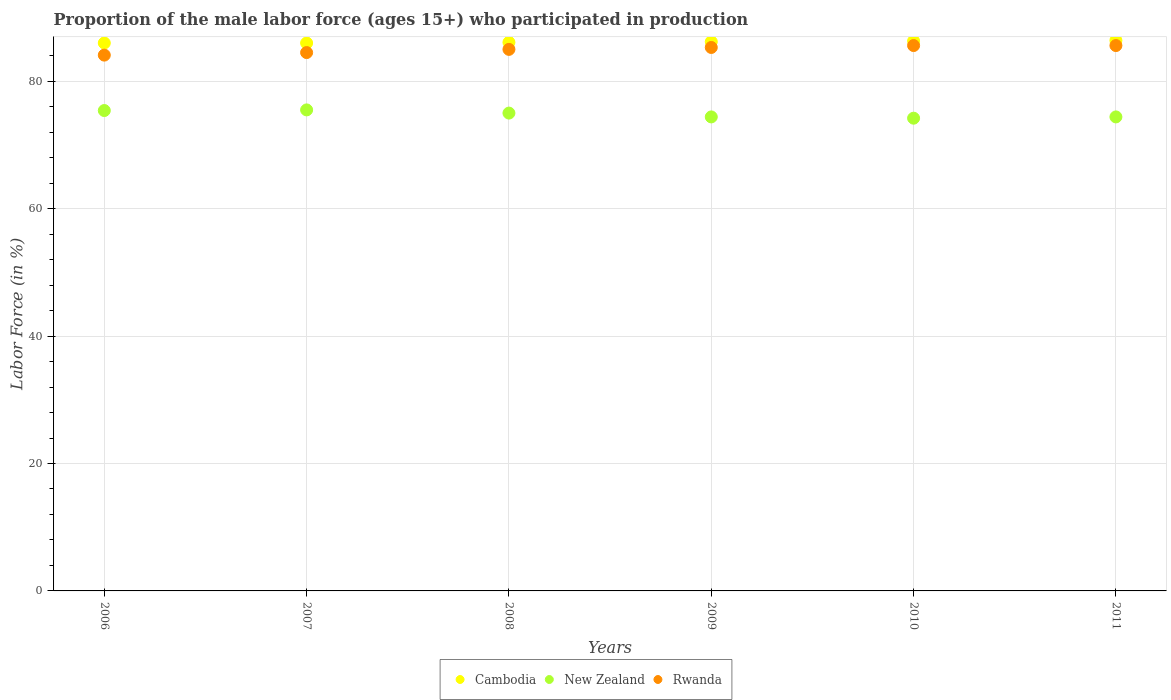What is the proportion of the male labor force who participated in production in Cambodia in 2007?
Your answer should be very brief. 86. Across all years, what is the maximum proportion of the male labor force who participated in production in New Zealand?
Offer a very short reply. 75.5. Across all years, what is the minimum proportion of the male labor force who participated in production in New Zealand?
Keep it short and to the point. 74.2. What is the total proportion of the male labor force who participated in production in Rwanda in the graph?
Keep it short and to the point. 510.1. What is the difference between the proportion of the male labor force who participated in production in New Zealand in 2009 and that in 2010?
Provide a succinct answer. 0.2. What is the difference between the proportion of the male labor force who participated in production in Rwanda in 2011 and the proportion of the male labor force who participated in production in New Zealand in 2007?
Your answer should be very brief. 10.1. What is the average proportion of the male labor force who participated in production in New Zealand per year?
Give a very brief answer. 74.82. In how many years, is the proportion of the male labor force who participated in production in Rwanda greater than 16 %?
Your answer should be compact. 6. What is the ratio of the proportion of the male labor force who participated in production in New Zealand in 2010 to that in 2011?
Offer a terse response. 1. Is the difference between the proportion of the male labor force who participated in production in New Zealand in 2006 and 2008 greater than the difference between the proportion of the male labor force who participated in production in Rwanda in 2006 and 2008?
Ensure brevity in your answer.  Yes. What is the difference between the highest and the second highest proportion of the male labor force who participated in production in Cambodia?
Provide a succinct answer. 0.1. What is the difference between the highest and the lowest proportion of the male labor force who participated in production in Rwanda?
Keep it short and to the point. 1.5. In how many years, is the proportion of the male labor force who participated in production in Cambodia greater than the average proportion of the male labor force who participated in production in Cambodia taken over all years?
Your response must be concise. 3. Is it the case that in every year, the sum of the proportion of the male labor force who participated in production in Rwanda and proportion of the male labor force who participated in production in New Zealand  is greater than the proportion of the male labor force who participated in production in Cambodia?
Ensure brevity in your answer.  Yes. Is the proportion of the male labor force who participated in production in New Zealand strictly greater than the proportion of the male labor force who participated in production in Cambodia over the years?
Make the answer very short. No. How many dotlines are there?
Offer a very short reply. 3. How many years are there in the graph?
Give a very brief answer. 6. What is the difference between two consecutive major ticks on the Y-axis?
Make the answer very short. 20. Does the graph contain grids?
Your answer should be very brief. Yes. Where does the legend appear in the graph?
Offer a terse response. Bottom center. How are the legend labels stacked?
Keep it short and to the point. Horizontal. What is the title of the graph?
Your response must be concise. Proportion of the male labor force (ages 15+) who participated in production. Does "Heavily indebted poor countries" appear as one of the legend labels in the graph?
Make the answer very short. No. What is the Labor Force (in %) of Cambodia in 2006?
Make the answer very short. 86. What is the Labor Force (in %) in New Zealand in 2006?
Ensure brevity in your answer.  75.4. What is the Labor Force (in %) in Rwanda in 2006?
Offer a very short reply. 84.1. What is the Labor Force (in %) in New Zealand in 2007?
Your response must be concise. 75.5. What is the Labor Force (in %) in Rwanda in 2007?
Give a very brief answer. 84.5. What is the Labor Force (in %) of Cambodia in 2008?
Give a very brief answer. 86.1. What is the Labor Force (in %) of Rwanda in 2008?
Ensure brevity in your answer.  85. What is the Labor Force (in %) in Cambodia in 2009?
Your answer should be very brief. 86.2. What is the Labor Force (in %) of New Zealand in 2009?
Give a very brief answer. 74.4. What is the Labor Force (in %) in Rwanda in 2009?
Provide a succinct answer. 85.3. What is the Labor Force (in %) in Cambodia in 2010?
Provide a succinct answer. 86.3. What is the Labor Force (in %) in New Zealand in 2010?
Provide a short and direct response. 74.2. What is the Labor Force (in %) of Rwanda in 2010?
Give a very brief answer. 85.6. What is the Labor Force (in %) of Cambodia in 2011?
Your response must be concise. 86.4. What is the Labor Force (in %) in New Zealand in 2011?
Make the answer very short. 74.4. What is the Labor Force (in %) in Rwanda in 2011?
Make the answer very short. 85.6. Across all years, what is the maximum Labor Force (in %) in Cambodia?
Your answer should be compact. 86.4. Across all years, what is the maximum Labor Force (in %) of New Zealand?
Make the answer very short. 75.5. Across all years, what is the maximum Labor Force (in %) in Rwanda?
Give a very brief answer. 85.6. Across all years, what is the minimum Labor Force (in %) in Cambodia?
Offer a very short reply. 86. Across all years, what is the minimum Labor Force (in %) in New Zealand?
Offer a very short reply. 74.2. Across all years, what is the minimum Labor Force (in %) in Rwanda?
Offer a very short reply. 84.1. What is the total Labor Force (in %) of Cambodia in the graph?
Ensure brevity in your answer.  517. What is the total Labor Force (in %) of New Zealand in the graph?
Ensure brevity in your answer.  448.9. What is the total Labor Force (in %) of Rwanda in the graph?
Provide a short and direct response. 510.1. What is the difference between the Labor Force (in %) of Cambodia in 2006 and that in 2007?
Your answer should be very brief. 0. What is the difference between the Labor Force (in %) in New Zealand in 2006 and that in 2007?
Your answer should be compact. -0.1. What is the difference between the Labor Force (in %) of Rwanda in 2006 and that in 2008?
Provide a short and direct response. -0.9. What is the difference between the Labor Force (in %) in New Zealand in 2006 and that in 2009?
Keep it short and to the point. 1. What is the difference between the Labor Force (in %) of Rwanda in 2006 and that in 2010?
Give a very brief answer. -1.5. What is the difference between the Labor Force (in %) in Cambodia in 2006 and that in 2011?
Your answer should be very brief. -0.4. What is the difference between the Labor Force (in %) in Cambodia in 2007 and that in 2009?
Make the answer very short. -0.2. What is the difference between the Labor Force (in %) of Cambodia in 2007 and that in 2010?
Your answer should be compact. -0.3. What is the difference between the Labor Force (in %) in Cambodia in 2007 and that in 2011?
Make the answer very short. -0.4. What is the difference between the Labor Force (in %) in Rwanda in 2007 and that in 2011?
Keep it short and to the point. -1.1. What is the difference between the Labor Force (in %) of Cambodia in 2008 and that in 2009?
Ensure brevity in your answer.  -0.1. What is the difference between the Labor Force (in %) of New Zealand in 2008 and that in 2009?
Give a very brief answer. 0.6. What is the difference between the Labor Force (in %) in Rwanda in 2008 and that in 2009?
Your answer should be compact. -0.3. What is the difference between the Labor Force (in %) of Cambodia in 2008 and that in 2010?
Provide a short and direct response. -0.2. What is the difference between the Labor Force (in %) in New Zealand in 2008 and that in 2010?
Provide a short and direct response. 0.8. What is the difference between the Labor Force (in %) in Rwanda in 2008 and that in 2010?
Offer a very short reply. -0.6. What is the difference between the Labor Force (in %) of Rwanda in 2008 and that in 2011?
Keep it short and to the point. -0.6. What is the difference between the Labor Force (in %) in Cambodia in 2009 and that in 2010?
Keep it short and to the point. -0.1. What is the difference between the Labor Force (in %) in Cambodia in 2009 and that in 2011?
Provide a succinct answer. -0.2. What is the difference between the Labor Force (in %) in New Zealand in 2009 and that in 2011?
Give a very brief answer. 0. What is the difference between the Labor Force (in %) of Rwanda in 2009 and that in 2011?
Offer a terse response. -0.3. What is the difference between the Labor Force (in %) in New Zealand in 2010 and that in 2011?
Offer a very short reply. -0.2. What is the difference between the Labor Force (in %) in Rwanda in 2010 and that in 2011?
Offer a very short reply. 0. What is the difference between the Labor Force (in %) of Cambodia in 2006 and the Labor Force (in %) of New Zealand in 2007?
Your answer should be compact. 10.5. What is the difference between the Labor Force (in %) of Cambodia in 2006 and the Labor Force (in %) of Rwanda in 2007?
Keep it short and to the point. 1.5. What is the difference between the Labor Force (in %) of New Zealand in 2006 and the Labor Force (in %) of Rwanda in 2008?
Give a very brief answer. -9.6. What is the difference between the Labor Force (in %) of New Zealand in 2006 and the Labor Force (in %) of Rwanda in 2009?
Your answer should be compact. -9.9. What is the difference between the Labor Force (in %) of Cambodia in 2006 and the Labor Force (in %) of New Zealand in 2010?
Offer a terse response. 11.8. What is the difference between the Labor Force (in %) in New Zealand in 2006 and the Labor Force (in %) in Rwanda in 2010?
Your answer should be very brief. -10.2. What is the difference between the Labor Force (in %) in Cambodia in 2006 and the Labor Force (in %) in Rwanda in 2011?
Provide a short and direct response. 0.4. What is the difference between the Labor Force (in %) in New Zealand in 2006 and the Labor Force (in %) in Rwanda in 2011?
Offer a terse response. -10.2. What is the difference between the Labor Force (in %) in Cambodia in 2007 and the Labor Force (in %) in Rwanda in 2008?
Your response must be concise. 1. What is the difference between the Labor Force (in %) in Cambodia in 2007 and the Labor Force (in %) in New Zealand in 2009?
Your response must be concise. 11.6. What is the difference between the Labor Force (in %) in New Zealand in 2008 and the Labor Force (in %) in Rwanda in 2009?
Your response must be concise. -10.3. What is the difference between the Labor Force (in %) in Cambodia in 2008 and the Labor Force (in %) in New Zealand in 2010?
Offer a very short reply. 11.9. What is the difference between the Labor Force (in %) of New Zealand in 2008 and the Labor Force (in %) of Rwanda in 2010?
Offer a terse response. -10.6. What is the difference between the Labor Force (in %) of New Zealand in 2008 and the Labor Force (in %) of Rwanda in 2011?
Provide a short and direct response. -10.6. What is the difference between the Labor Force (in %) in New Zealand in 2009 and the Labor Force (in %) in Rwanda in 2010?
Offer a terse response. -11.2. What is the difference between the Labor Force (in %) of Cambodia in 2009 and the Labor Force (in %) of New Zealand in 2011?
Provide a short and direct response. 11.8. What is the difference between the Labor Force (in %) of Cambodia in 2009 and the Labor Force (in %) of Rwanda in 2011?
Provide a short and direct response. 0.6. What is the difference between the Labor Force (in %) in New Zealand in 2009 and the Labor Force (in %) in Rwanda in 2011?
Ensure brevity in your answer.  -11.2. What is the difference between the Labor Force (in %) in Cambodia in 2010 and the Labor Force (in %) in New Zealand in 2011?
Provide a short and direct response. 11.9. What is the difference between the Labor Force (in %) in New Zealand in 2010 and the Labor Force (in %) in Rwanda in 2011?
Offer a terse response. -11.4. What is the average Labor Force (in %) of Cambodia per year?
Offer a very short reply. 86.17. What is the average Labor Force (in %) in New Zealand per year?
Provide a succinct answer. 74.82. What is the average Labor Force (in %) in Rwanda per year?
Provide a short and direct response. 85.02. In the year 2006, what is the difference between the Labor Force (in %) of Cambodia and Labor Force (in %) of Rwanda?
Keep it short and to the point. 1.9. In the year 2006, what is the difference between the Labor Force (in %) of New Zealand and Labor Force (in %) of Rwanda?
Ensure brevity in your answer.  -8.7. In the year 2007, what is the difference between the Labor Force (in %) of Cambodia and Labor Force (in %) of Rwanda?
Offer a terse response. 1.5. In the year 2008, what is the difference between the Labor Force (in %) of Cambodia and Labor Force (in %) of Rwanda?
Give a very brief answer. 1.1. In the year 2008, what is the difference between the Labor Force (in %) of New Zealand and Labor Force (in %) of Rwanda?
Provide a succinct answer. -10. In the year 2009, what is the difference between the Labor Force (in %) of New Zealand and Labor Force (in %) of Rwanda?
Offer a very short reply. -10.9. In the year 2010, what is the difference between the Labor Force (in %) of New Zealand and Labor Force (in %) of Rwanda?
Ensure brevity in your answer.  -11.4. In the year 2011, what is the difference between the Labor Force (in %) of Cambodia and Labor Force (in %) of Rwanda?
Keep it short and to the point. 0.8. What is the ratio of the Labor Force (in %) of New Zealand in 2006 to that in 2007?
Offer a very short reply. 1. What is the ratio of the Labor Force (in %) in Rwanda in 2006 to that in 2007?
Give a very brief answer. 1. What is the ratio of the Labor Force (in %) in Cambodia in 2006 to that in 2008?
Provide a succinct answer. 1. What is the ratio of the Labor Force (in %) in New Zealand in 2006 to that in 2008?
Provide a succinct answer. 1.01. What is the ratio of the Labor Force (in %) of Rwanda in 2006 to that in 2008?
Your answer should be compact. 0.99. What is the ratio of the Labor Force (in %) in Cambodia in 2006 to that in 2009?
Your answer should be very brief. 1. What is the ratio of the Labor Force (in %) of New Zealand in 2006 to that in 2009?
Your answer should be very brief. 1.01. What is the ratio of the Labor Force (in %) of Rwanda in 2006 to that in 2009?
Give a very brief answer. 0.99. What is the ratio of the Labor Force (in %) of Cambodia in 2006 to that in 2010?
Offer a very short reply. 1. What is the ratio of the Labor Force (in %) of New Zealand in 2006 to that in 2010?
Provide a short and direct response. 1.02. What is the ratio of the Labor Force (in %) in Rwanda in 2006 to that in 2010?
Offer a very short reply. 0.98. What is the ratio of the Labor Force (in %) in New Zealand in 2006 to that in 2011?
Your answer should be compact. 1.01. What is the ratio of the Labor Force (in %) of Rwanda in 2006 to that in 2011?
Keep it short and to the point. 0.98. What is the ratio of the Labor Force (in %) of Cambodia in 2007 to that in 2008?
Your answer should be very brief. 1. What is the ratio of the Labor Force (in %) in New Zealand in 2007 to that in 2008?
Your response must be concise. 1.01. What is the ratio of the Labor Force (in %) of Cambodia in 2007 to that in 2009?
Your response must be concise. 1. What is the ratio of the Labor Force (in %) of New Zealand in 2007 to that in 2009?
Your answer should be compact. 1.01. What is the ratio of the Labor Force (in %) of Rwanda in 2007 to that in 2009?
Make the answer very short. 0.99. What is the ratio of the Labor Force (in %) of Cambodia in 2007 to that in 2010?
Ensure brevity in your answer.  1. What is the ratio of the Labor Force (in %) in New Zealand in 2007 to that in 2010?
Make the answer very short. 1.02. What is the ratio of the Labor Force (in %) of Rwanda in 2007 to that in 2010?
Provide a succinct answer. 0.99. What is the ratio of the Labor Force (in %) of Cambodia in 2007 to that in 2011?
Your response must be concise. 1. What is the ratio of the Labor Force (in %) in New Zealand in 2007 to that in 2011?
Your answer should be compact. 1.01. What is the ratio of the Labor Force (in %) of Rwanda in 2007 to that in 2011?
Give a very brief answer. 0.99. What is the ratio of the Labor Force (in %) in Cambodia in 2008 to that in 2009?
Keep it short and to the point. 1. What is the ratio of the Labor Force (in %) in New Zealand in 2008 to that in 2009?
Offer a terse response. 1.01. What is the ratio of the Labor Force (in %) in Cambodia in 2008 to that in 2010?
Make the answer very short. 1. What is the ratio of the Labor Force (in %) in New Zealand in 2008 to that in 2010?
Your answer should be very brief. 1.01. What is the ratio of the Labor Force (in %) of Rwanda in 2008 to that in 2010?
Your answer should be compact. 0.99. What is the ratio of the Labor Force (in %) in Cambodia in 2008 to that in 2011?
Your answer should be very brief. 1. What is the ratio of the Labor Force (in %) of New Zealand in 2008 to that in 2011?
Your response must be concise. 1.01. What is the ratio of the Labor Force (in %) in Rwanda in 2008 to that in 2011?
Provide a succinct answer. 0.99. What is the ratio of the Labor Force (in %) of Cambodia in 2009 to that in 2010?
Your answer should be very brief. 1. What is the ratio of the Labor Force (in %) in Rwanda in 2009 to that in 2010?
Offer a terse response. 1. What is the ratio of the Labor Force (in %) of Cambodia in 2010 to that in 2011?
Make the answer very short. 1. What is the difference between the highest and the second highest Labor Force (in %) in Cambodia?
Make the answer very short. 0.1. What is the difference between the highest and the second highest Labor Force (in %) in New Zealand?
Your response must be concise. 0.1. 